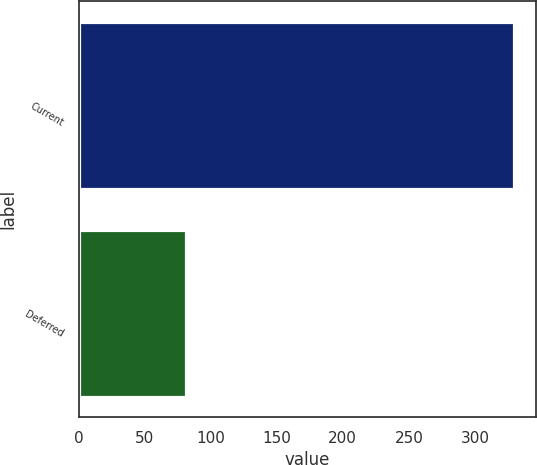Convert chart to OTSL. <chart><loc_0><loc_0><loc_500><loc_500><bar_chart><fcel>Current<fcel>Deferred<nl><fcel>330<fcel>81<nl></chart> 